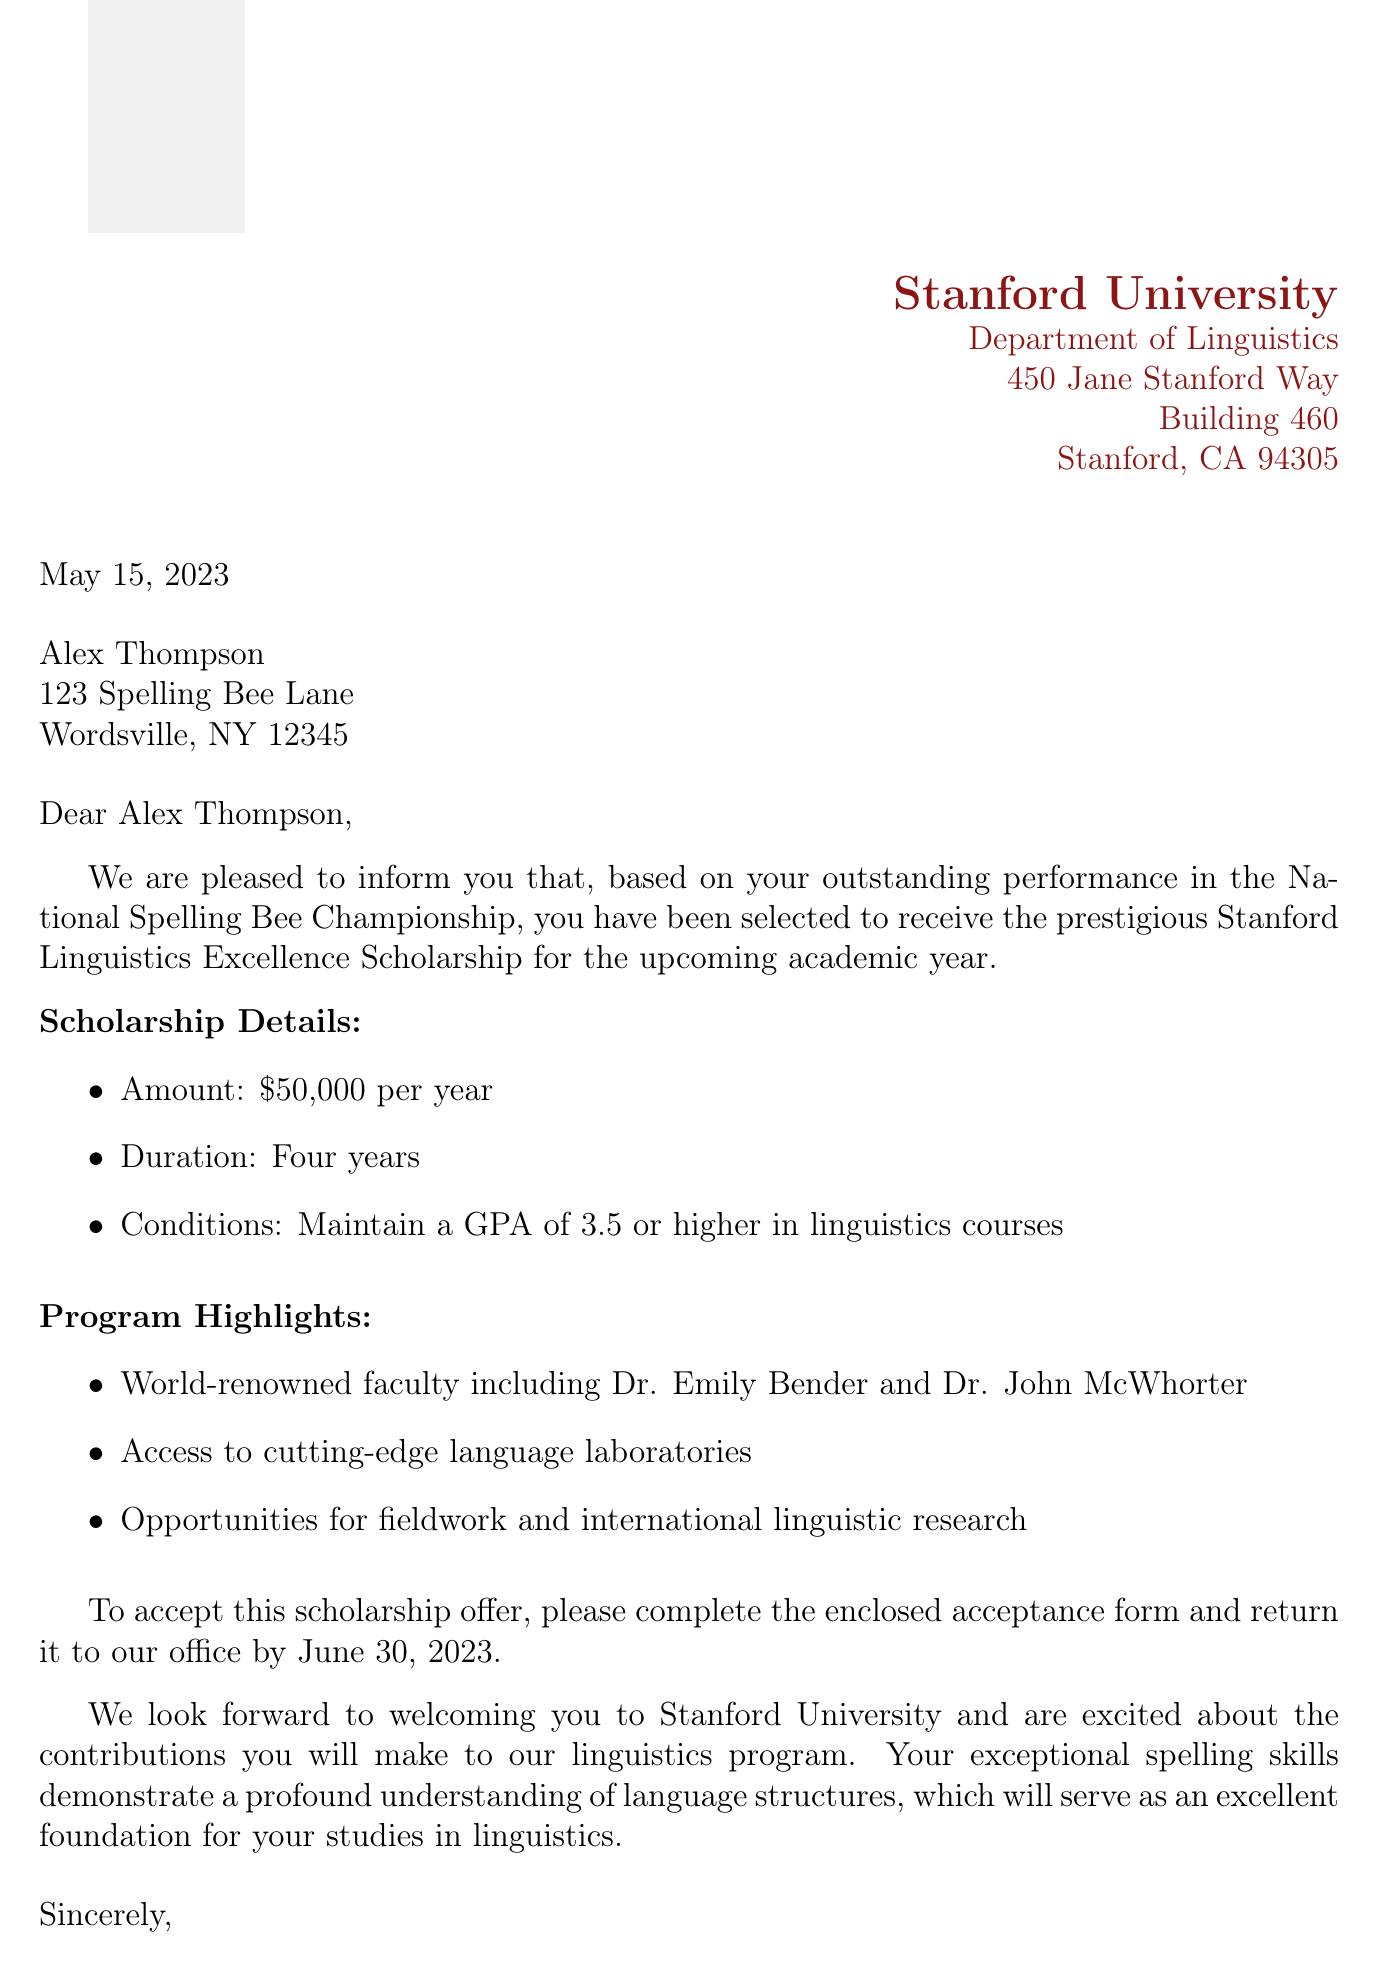What is the name of the scholarship? The letter states that the scholarship is called the Stanford Linguistics Excellence Scholarship.
Answer: Stanford Linguistics Excellence Scholarship What is the scholarship amount per year? The document specifies that the scholarship amount is $50,000 per year.
Answer: $50,000 per year Who is the recipient of this letter? The letter is addressed to Alex Thompson, who is the recipient.
Answer: Alex Thompson What is the deadline to accept the scholarship offer? The document mentions that the acceptance form must be returned by June 30, 2023.
Answer: June 30, 2023 What GPA must be maintained to keep the scholarship? According to the document, a GPA of 3.5 or higher in linguistics courses must be maintained.
Answer: 3.5 or higher Which department is offering the scholarship? The scholarship is offered by the Department of Linguistics at Stanford University.
Answer: Department of Linguistics Who signed the letter? The letter is signed by Dr. Sarah Collins.
Answer: Dr. Sarah Collins What are the program highlights mentioned in the letter? The program highlights include world-renowned faculty, access to language laboratories, and opportunities for fieldwork.
Answer: World-renowned faculty, cutting-edge language laboratories, international linguistic research What is one reason mentioned for selecting Alex Thompson for the scholarship? The letter cites Alex Thompson's outstanding performance in the National Spelling Bee Championship as a reason for the selection.
Answer: Outstanding performance in the National Spelling Bee Championship 